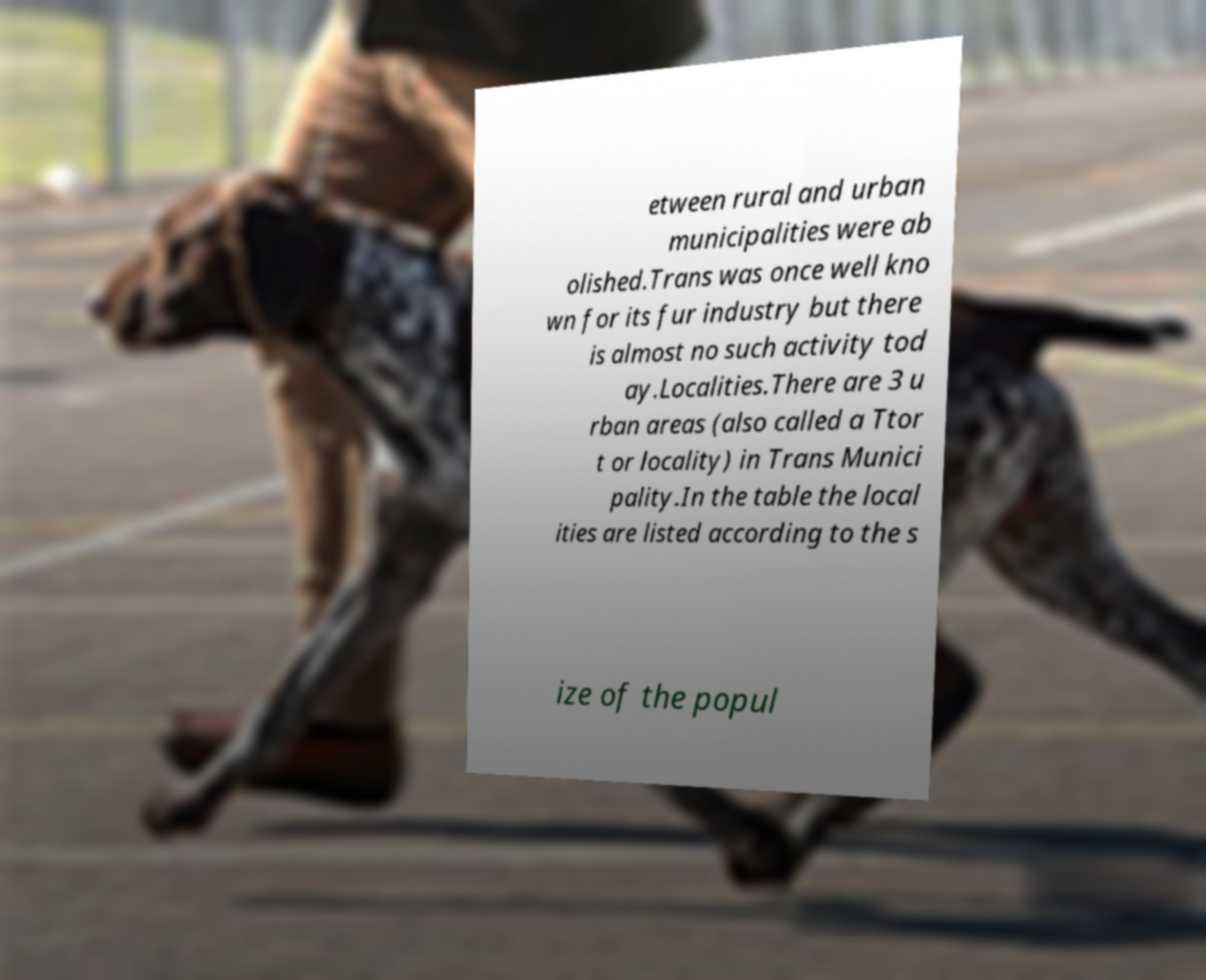Could you assist in decoding the text presented in this image and type it out clearly? etween rural and urban municipalities were ab olished.Trans was once well kno wn for its fur industry but there is almost no such activity tod ay.Localities.There are 3 u rban areas (also called a Ttor t or locality) in Trans Munici pality.In the table the local ities are listed according to the s ize of the popul 